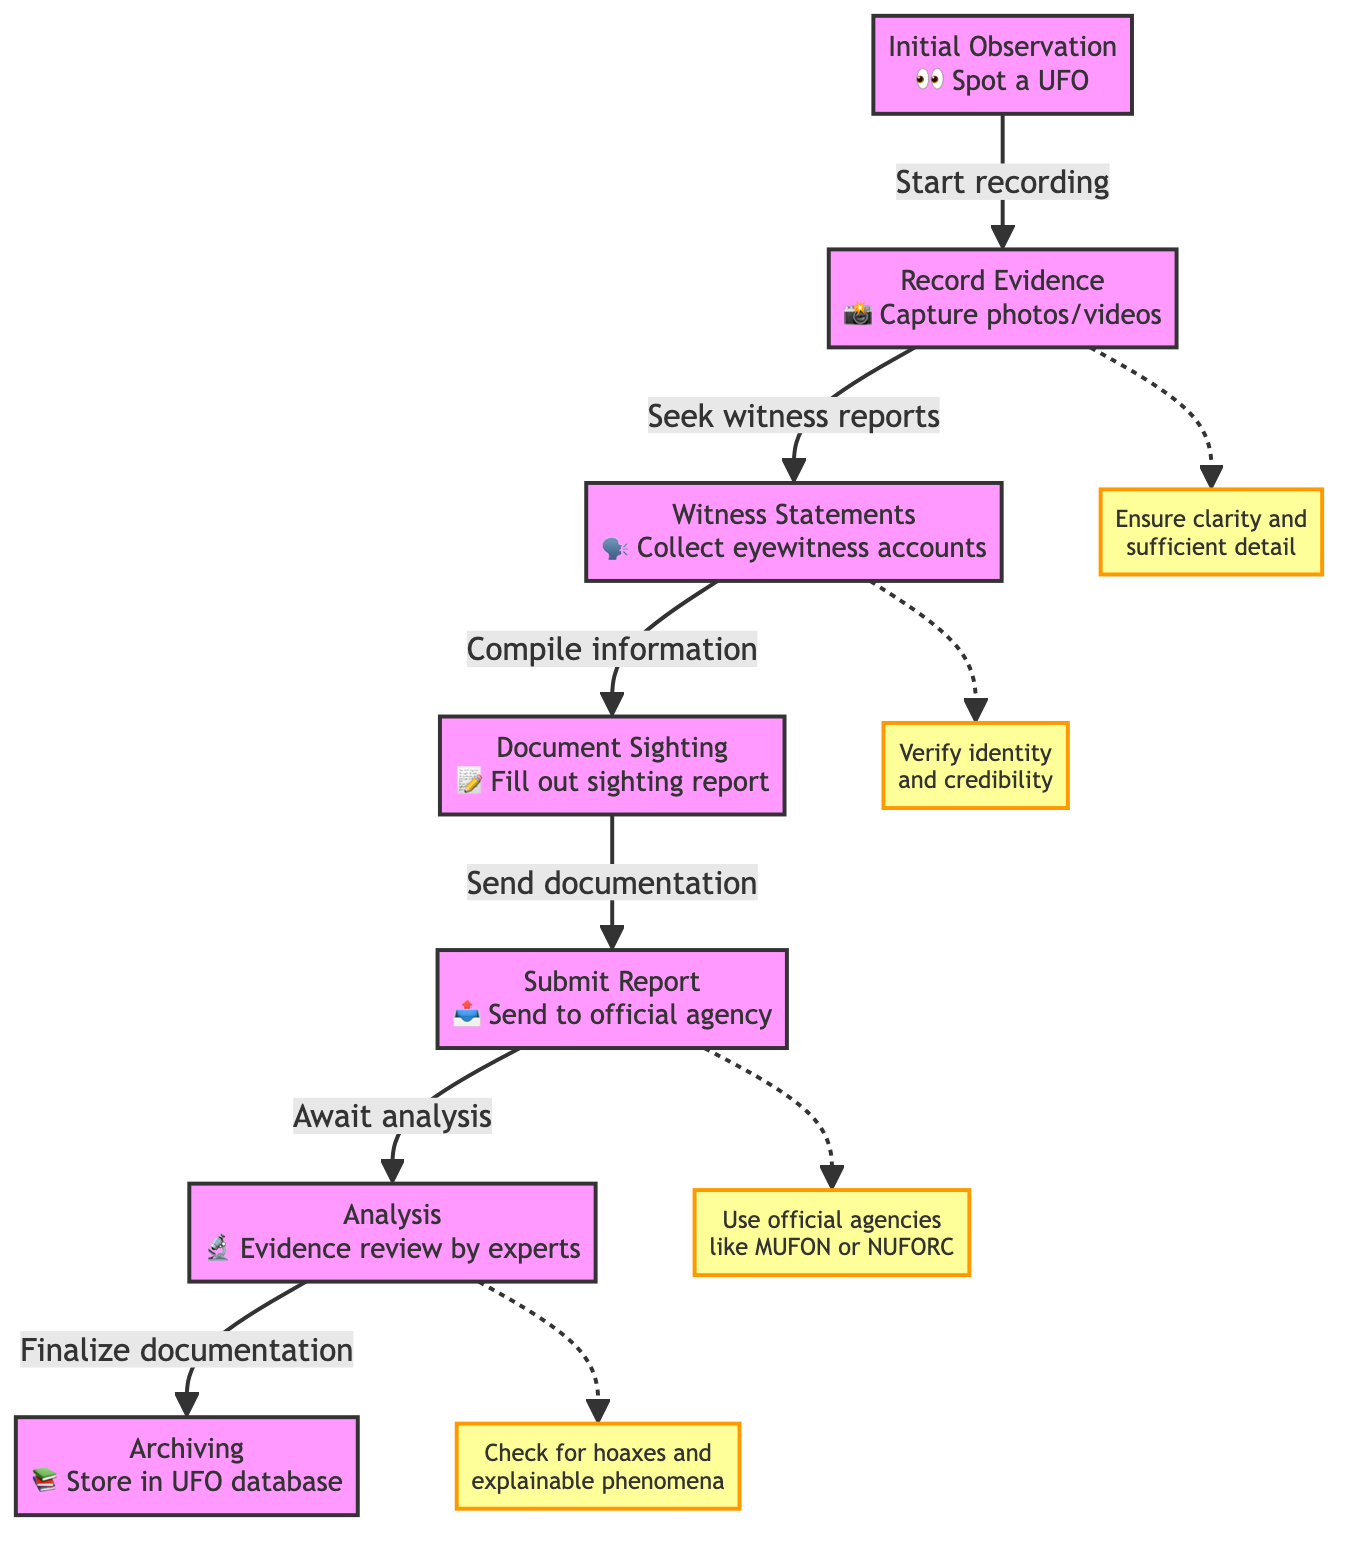What is the first step in the UFO sighting reporting process? The diagram indicates that the initial step in the reporting process is "Initial Observation," where one spots a UFO. This is the starting point of the flowchart and clearly labeled as the first action.
Answer: Initial Observation How many main steps are there in the UFO sighting report flow? By examining the flowchart, we can identify six main steps: Initial Observation, Record Evidence, Witness Statements, Document Sighting, Submit Report, and Analysis. Thus, counting these distinct steps provides the answer.
Answer: Six Which step comes after recording evidence? The diagram shows that after the "Record Evidence" step, the next action is "Witness Statements." This is indicated by the directional arrow that flows from recording evidence to gathering witness reports.
Answer: Witness Statements What is the purpose of the callout in the 'Record Evidence' step? The callout associated with the "Record Evidence" step emphasizes the importance of ensuring clarity and sufficient detail in the recorded evidence. This provides a critical guideline to enhance the quality of the report and make it more understandable.
Answer: Ensure clarity and sufficient detail What does the 'Submit Report' step advise regarding official agencies? The flowchart's callout for the "Submit Report" step advises users to use official agencies like MUFON or NUFORC for submission. This is a critical guideline that underscores which agencies are recommended for report submission.
Answer: Use official agencies like MUFON or NUFORC What happens to the report after it is submitted? According to the flowchart, once the report is submitted, the next action is to "Await analysis." This indicates a waiting period for the report to be reviewed by experts before further actions are taken.
Answer: Await analysis How is evidence treated after analysis? The diagram specifies that after analysis, the documentation is finalized and then archived in a UFO database, indicating that evidence is systematically stored for future reference.
Answer: Archive in UFO database What guideline is associated with witnessing statements in the flow? The callout linked to the "Witness Statements" step highlights the need to verify the identity and credibility of witnesses. This is crucial for ensuring the reliability of the reports collected.
Answer: Verify identity and credibility 